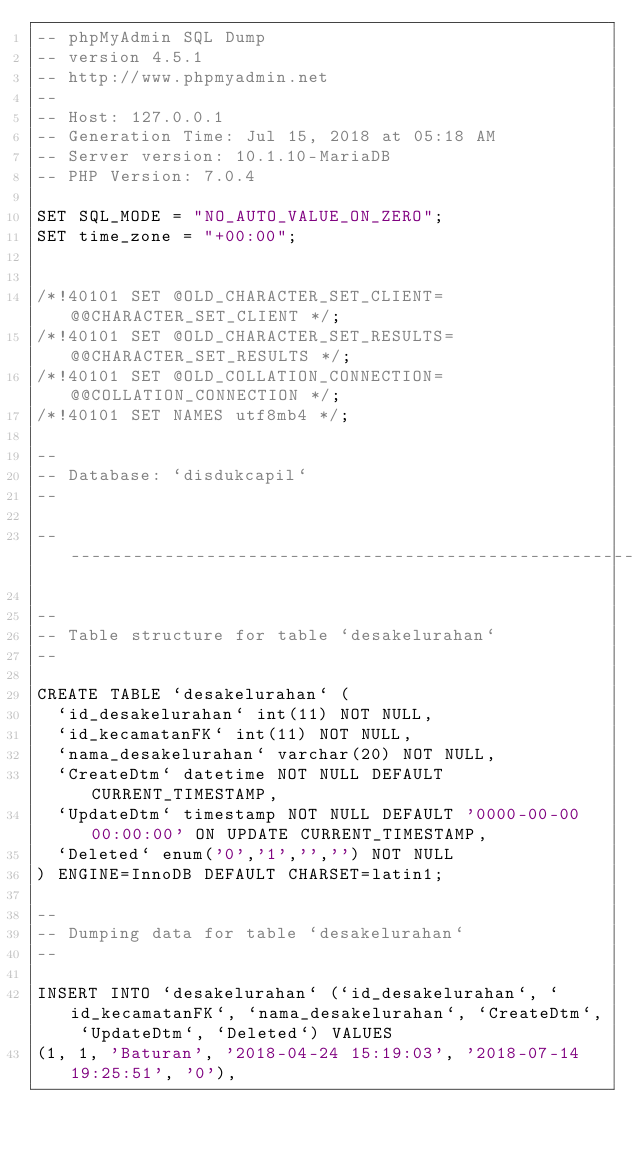Convert code to text. <code><loc_0><loc_0><loc_500><loc_500><_SQL_>-- phpMyAdmin SQL Dump
-- version 4.5.1
-- http://www.phpmyadmin.net
--
-- Host: 127.0.0.1
-- Generation Time: Jul 15, 2018 at 05:18 AM
-- Server version: 10.1.10-MariaDB
-- PHP Version: 7.0.4

SET SQL_MODE = "NO_AUTO_VALUE_ON_ZERO";
SET time_zone = "+00:00";


/*!40101 SET @OLD_CHARACTER_SET_CLIENT=@@CHARACTER_SET_CLIENT */;
/*!40101 SET @OLD_CHARACTER_SET_RESULTS=@@CHARACTER_SET_RESULTS */;
/*!40101 SET @OLD_COLLATION_CONNECTION=@@COLLATION_CONNECTION */;
/*!40101 SET NAMES utf8mb4 */;

--
-- Database: `disdukcapil`
--

-- --------------------------------------------------------

--
-- Table structure for table `desakelurahan`
--

CREATE TABLE `desakelurahan` (
  `id_desakelurahan` int(11) NOT NULL,
  `id_kecamatanFK` int(11) NOT NULL,
  `nama_desakelurahan` varchar(20) NOT NULL,
  `CreateDtm` datetime NOT NULL DEFAULT CURRENT_TIMESTAMP,
  `UpdateDtm` timestamp NOT NULL DEFAULT '0000-00-00 00:00:00' ON UPDATE CURRENT_TIMESTAMP,
  `Deleted` enum('0','1','','') NOT NULL
) ENGINE=InnoDB DEFAULT CHARSET=latin1;

--
-- Dumping data for table `desakelurahan`
--

INSERT INTO `desakelurahan` (`id_desakelurahan`, `id_kecamatanFK`, `nama_desakelurahan`, `CreateDtm`, `UpdateDtm`, `Deleted`) VALUES
(1, 1, 'Baturan', '2018-04-24 15:19:03', '2018-07-14 19:25:51', '0'),</code> 